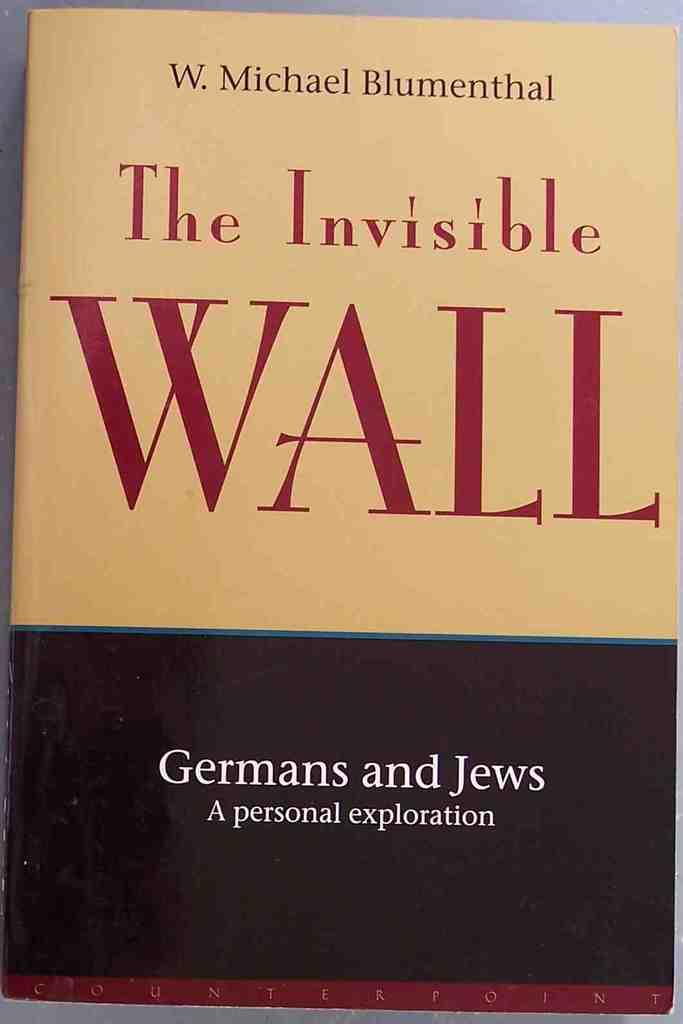Who wrote, "the invisible wall"?
Your answer should be compact. W. michael blumenthal. Is the bottom word counterpoint?
Provide a short and direct response. No. 